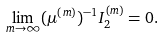<formula> <loc_0><loc_0><loc_500><loc_500>\lim _ { m \rightarrow \infty } ( \mu ^ { ( m ) } ) ^ { - 1 } I _ { 2 } ^ { ( m ) } = 0 .</formula> 